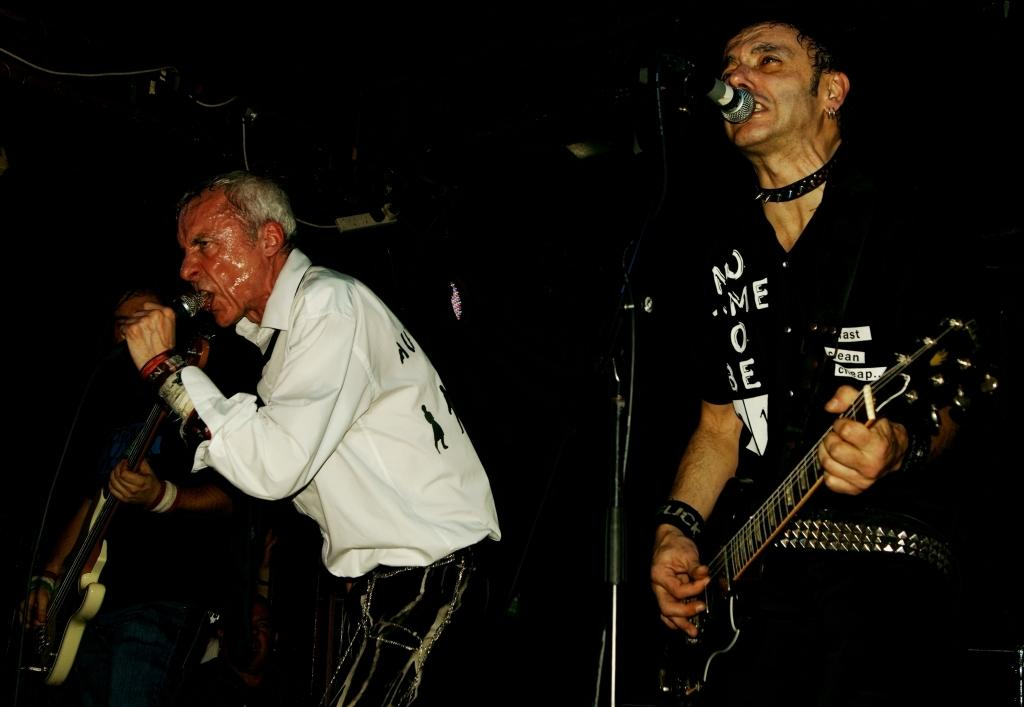How many people are in the image? There are two persons in the image. What are the two persons doing? They are singing. What object can be seen in front of them? They are in front of a microphone. Is there anyone else in the image besides the two singers? Yes, there is a man playing a guitar. What type of cakes can be seen on the guitar in the image? There are no cakes present in the image, and the guitar is not associated with any cakes. 